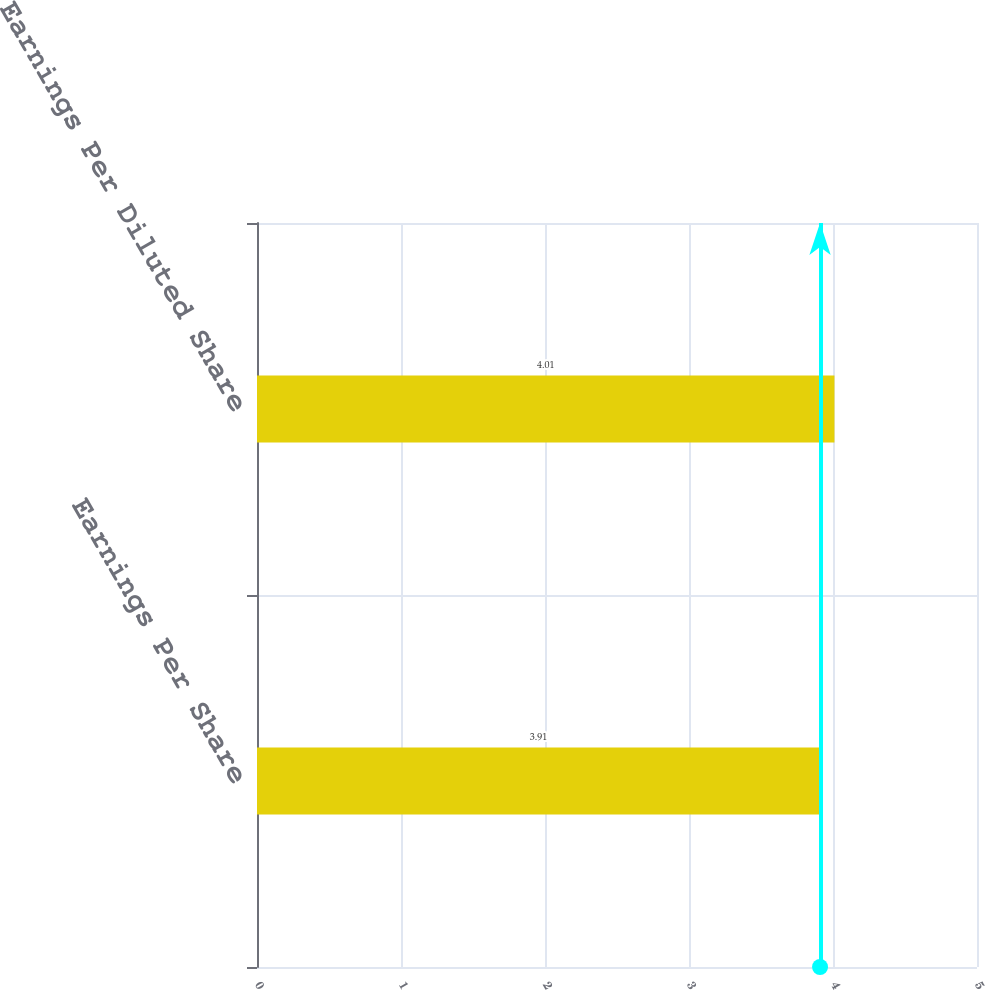<chart> <loc_0><loc_0><loc_500><loc_500><bar_chart><fcel>Earnings Per Share<fcel>Earnings Per Diluted Share<nl><fcel>3.91<fcel>4.01<nl></chart> 